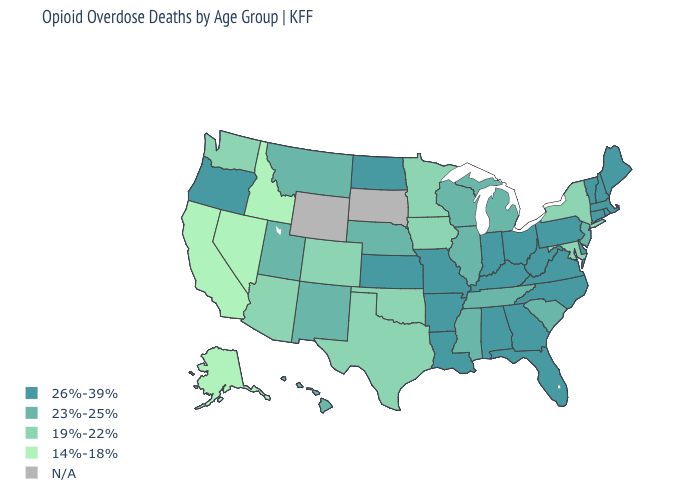Is the legend a continuous bar?
Answer briefly. No. Among the states that border Wyoming , which have the highest value?
Write a very short answer. Montana, Nebraska, Utah. Name the states that have a value in the range 14%-18%?
Give a very brief answer. Alaska, California, Idaho, Nevada. What is the value of Nebraska?
Be succinct. 23%-25%. Name the states that have a value in the range 23%-25%?
Quick response, please. Hawaii, Illinois, Michigan, Mississippi, Montana, Nebraska, New Jersey, New Mexico, South Carolina, Tennessee, Utah, Wisconsin. Among the states that border Tennessee , which have the highest value?
Be succinct. Alabama, Arkansas, Georgia, Kentucky, Missouri, North Carolina, Virginia. Which states have the lowest value in the Northeast?
Short answer required. New York. Which states have the lowest value in the USA?
Keep it brief. Alaska, California, Idaho, Nevada. Name the states that have a value in the range 26%-39%?
Write a very short answer. Alabama, Arkansas, Connecticut, Delaware, Florida, Georgia, Indiana, Kansas, Kentucky, Louisiana, Maine, Massachusetts, Missouri, New Hampshire, North Carolina, North Dakota, Ohio, Oregon, Pennsylvania, Rhode Island, Vermont, Virginia, West Virginia. Name the states that have a value in the range 26%-39%?
Answer briefly. Alabama, Arkansas, Connecticut, Delaware, Florida, Georgia, Indiana, Kansas, Kentucky, Louisiana, Maine, Massachusetts, Missouri, New Hampshire, North Carolina, North Dakota, Ohio, Oregon, Pennsylvania, Rhode Island, Vermont, Virginia, West Virginia. What is the value of Wisconsin?
Be succinct. 23%-25%. What is the value of Iowa?
Be succinct. 19%-22%. What is the lowest value in the USA?
Write a very short answer. 14%-18%. 